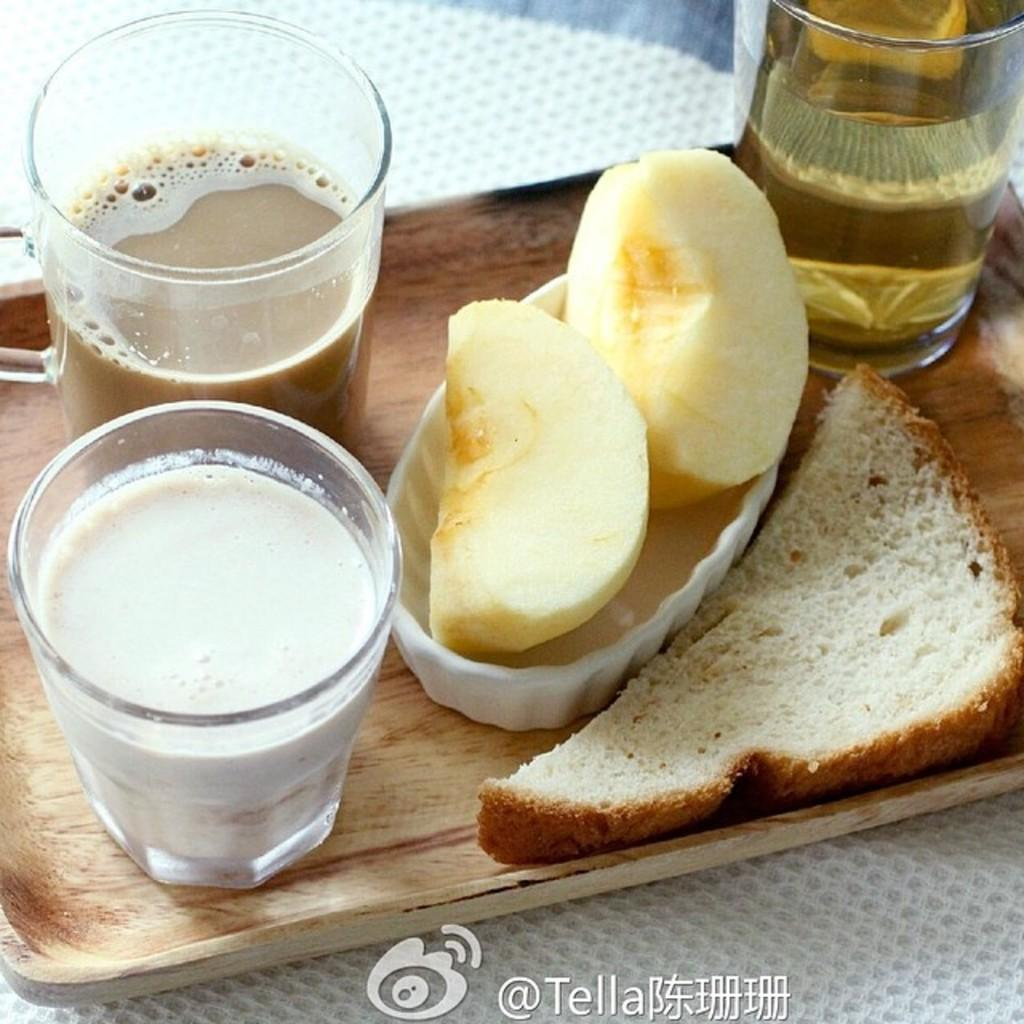What type of food can be seen in the image? There is a piece of bread and apple slices in the image. What are the drinks being served in the image? The drinks are in glasses in the image. Is there any text or marking visible in the image? Yes, there is a watermark at the bottom portion of the image. Can you tell me what page the bread and apple slices are on in the image? The image is a single image and does not have pages; it is a flat representation of the food items. Is there a snake visible in the image? No, there is no snake present in the image. 